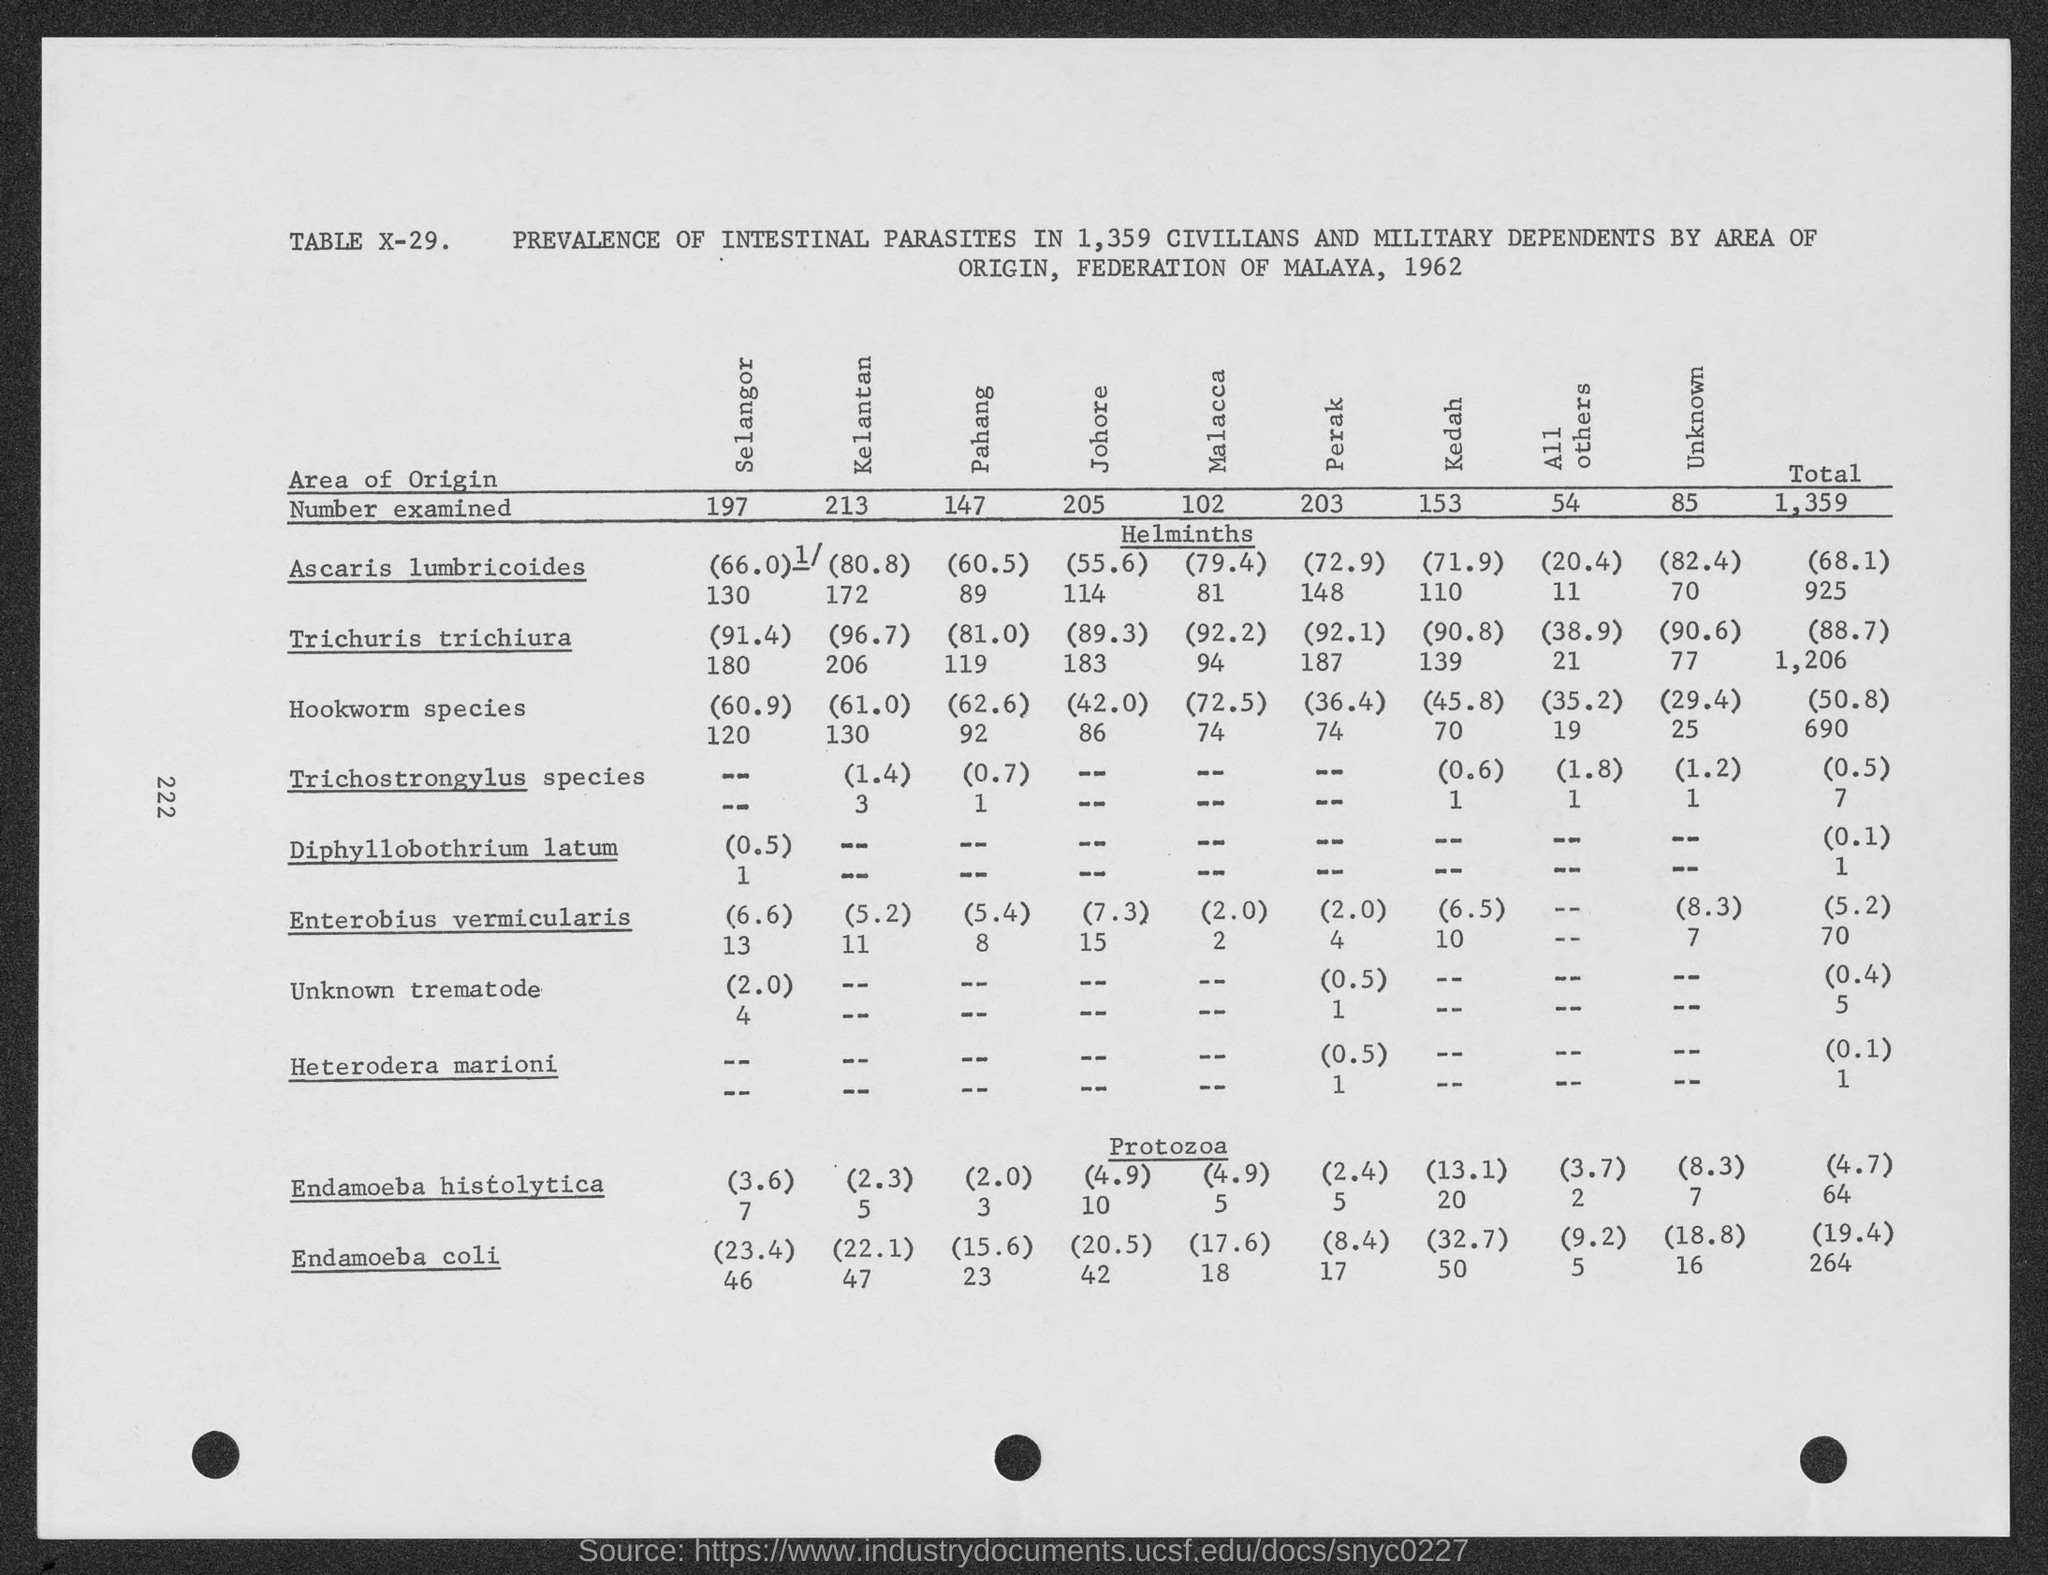What is the table number? The image displays table X-29, which presents data on the prevalence of intestinal parasites in 1,359 civilians and military dependents by area of origin, from the Federation of Malaya in 1962. 